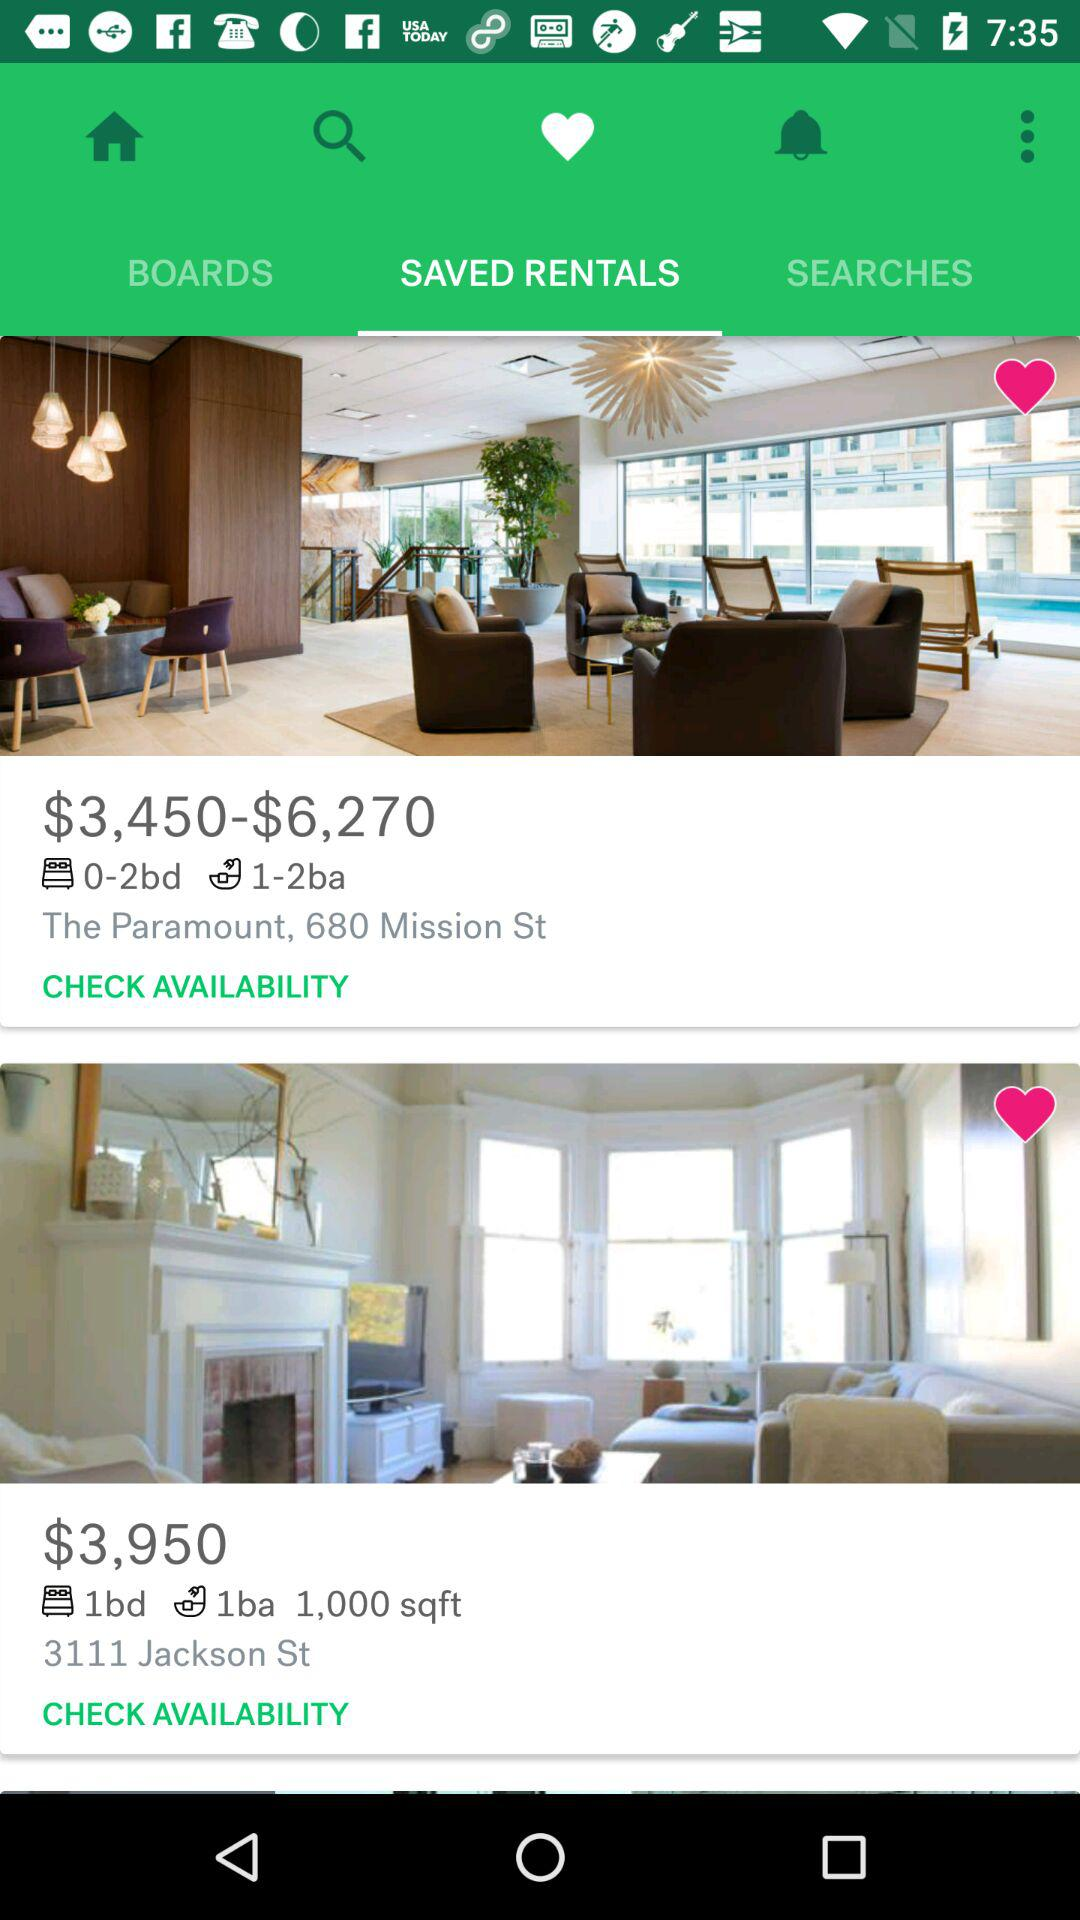What is the address of the property with 0–2 bedrooms and 1–2 bathrooms? The address of the property with 0–2 bedrooms and 1–2 bathrooms is The Paramount, 680 Mission St. 